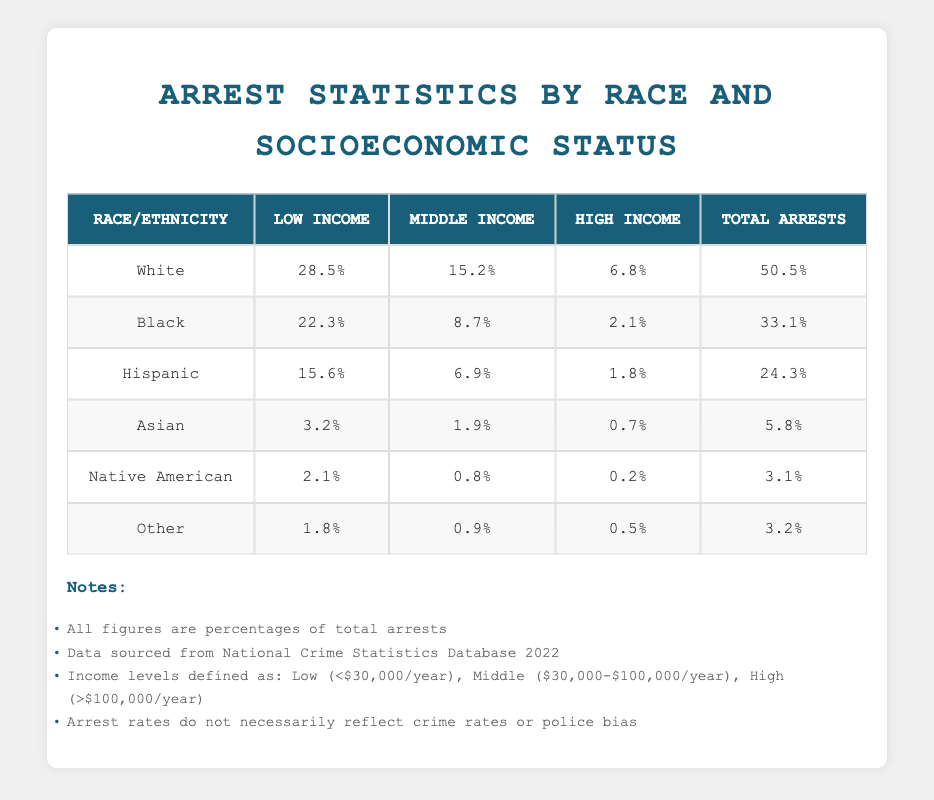What percentage of total arrests are attributed to White individuals? According to the table, the Total Arrests percentage for White individuals is 50.5%.
Answer: 50.5% Which racial/ethnic group has the highest percentage of low-income arrests? The group with the highest percentage of low-income arrests is White, with 28.5%.
Answer: White What is the difference in percentage of total arrests between Black and Hispanic individuals? Total arrests for Black individuals are 33.1% and for Hispanic individuals are 24.3%. The difference is 33.1% - 24.3% = 8.8%.
Answer: 8.8% True or False: More than half of the total arrests involve individuals from the High Income category. The table shows that the total percentage of arrests from the High Income category is 6.8% (White) + 2.1% (Black) + 1.8% (Hispanic) + 0.7% (Asian) + 0.2% (Native American) + 0.5% (Other) = 11.1%. This is not more than half.
Answer: False What is the total percentage of arrests made in the Middle Income category across all racial/ethnic groups? By adding the Middle Income percentages: 15.2% (White) + 8.7% (Black) + 6.9% (Hispanic) + 1.9% (Asian) + 0.8% (Native American) + 0.9% (Other) = 34.4%.
Answer: 34.4% Which group has the lowest percentage of total arrests and how much is it? The group with the lowest percentage of total arrests is Native American, at 3.1%.
Answer: 3.1% If you combine the Low Income arrests of Black and Hispanic groups, what is the total percentage? The Low Income percentages for Black and Hispanic groups are 22.3% and 15.6%, respectively. Adding these gives 22.3% + 15.6% = 37.9%.
Answer: 37.9% Are Asian individuals arrested at a higher percentage in the Low Income category compared to the High Income category? In the Low Income category, Asian individuals have 3.2%, while in the High Income category they have 0.7%. Thus, they are arrested at a higher percentage in the Low Income category.
Answer: Yes 